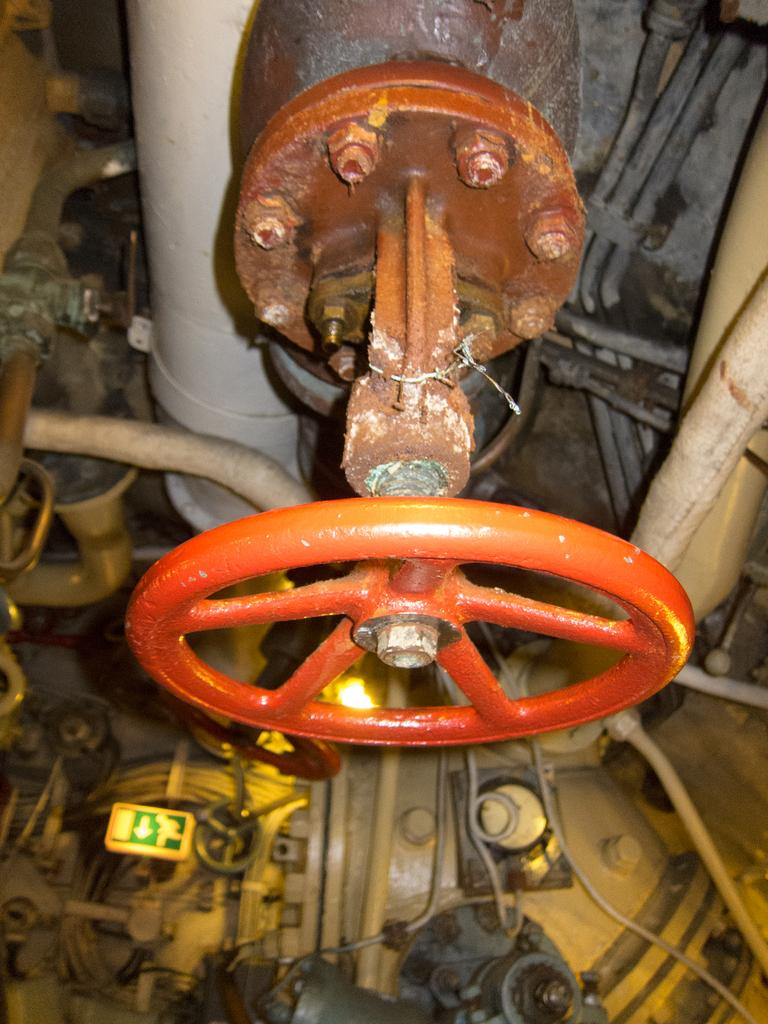What is one of the main objects in the image? There is a wheel in the image. What else can be seen in the image besides the wheel? There is a sign board, pipes, nuts, and other objects in the image. Can you describe the sign board in the image? The sign board is a separate object in the image. What type of objects are the nuts in the image? The nuts are small, round objects in the image. What type of sand can be seen in the image? There is no sand present in the image. How does the crow interact with the wheel in the image? There is no crow present in the image. 